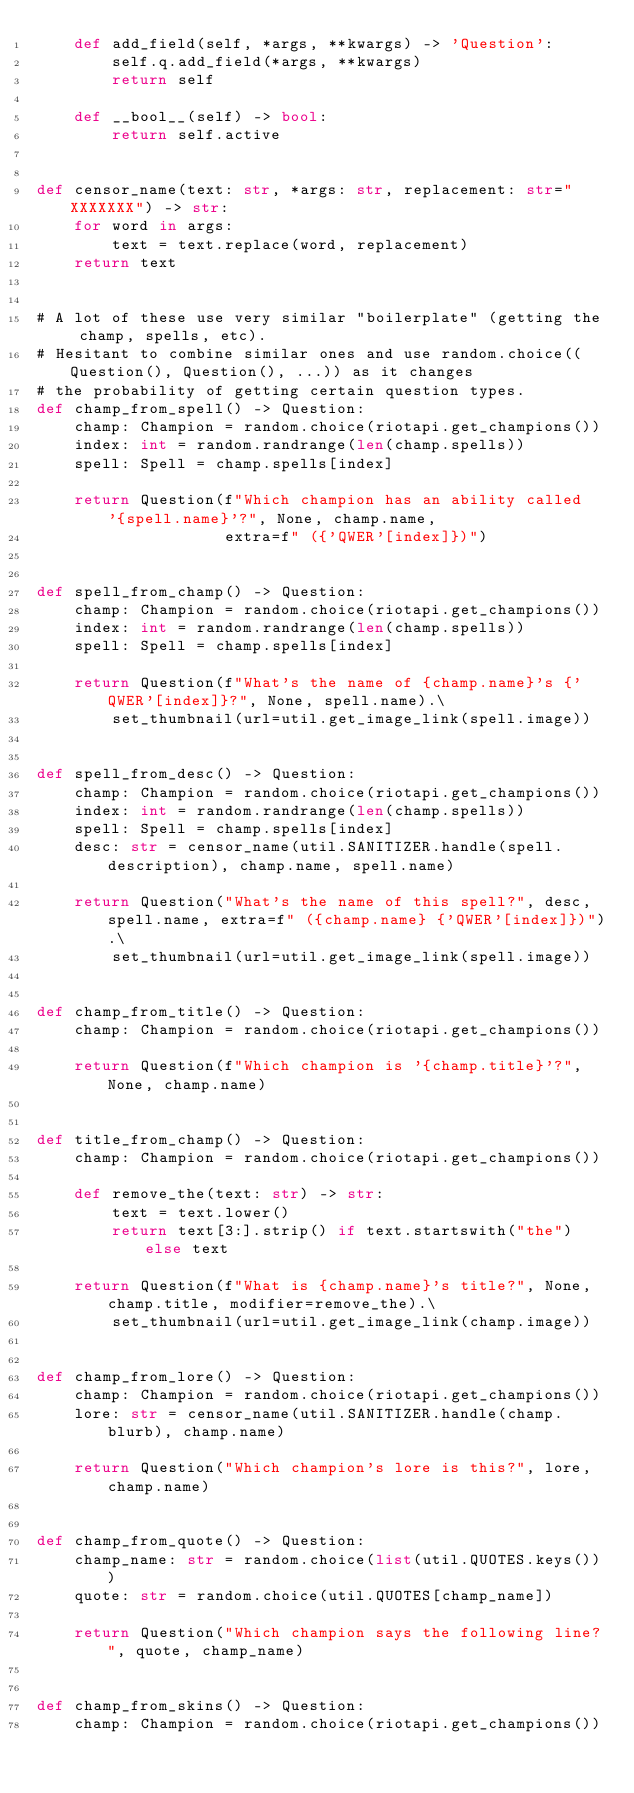Convert code to text. <code><loc_0><loc_0><loc_500><loc_500><_Python_>    def add_field(self, *args, **kwargs) -> 'Question':
        self.q.add_field(*args, **kwargs)
        return self

    def __bool__(self) -> bool:
        return self.active


def censor_name(text: str, *args: str, replacement: str="XXXXXXX") -> str:
    for word in args:
        text = text.replace(word, replacement)
    return text


# A lot of these use very similar "boilerplate" (getting the champ, spells, etc).
# Hesitant to combine similar ones and use random.choice((Question(), Question(), ...)) as it changes
# the probability of getting certain question types.
def champ_from_spell() -> Question:
    champ: Champion = random.choice(riotapi.get_champions())
    index: int = random.randrange(len(champ.spells))
    spell: Spell = champ.spells[index]

    return Question(f"Which champion has an ability called '{spell.name}'?", None, champ.name,
                    extra=f" ({'QWER'[index]})")


def spell_from_champ() -> Question:
    champ: Champion = random.choice(riotapi.get_champions())
    index: int = random.randrange(len(champ.spells))
    spell: Spell = champ.spells[index]

    return Question(f"What's the name of {champ.name}'s {'QWER'[index]}?", None, spell.name).\
        set_thumbnail(url=util.get_image_link(spell.image))


def spell_from_desc() -> Question:
    champ: Champion = random.choice(riotapi.get_champions())
    index: int = random.randrange(len(champ.spells))
    spell: Spell = champ.spells[index]
    desc: str = censor_name(util.SANITIZER.handle(spell.description), champ.name, spell.name)

    return Question("What's the name of this spell?", desc, spell.name, extra=f" ({champ.name} {'QWER'[index]})").\
        set_thumbnail(url=util.get_image_link(spell.image))


def champ_from_title() -> Question:
    champ: Champion = random.choice(riotapi.get_champions())

    return Question(f"Which champion is '{champ.title}'?", None, champ.name)


def title_from_champ() -> Question:
    champ: Champion = random.choice(riotapi.get_champions())

    def remove_the(text: str) -> str:
        text = text.lower()
        return text[3:].strip() if text.startswith("the") else text

    return Question(f"What is {champ.name}'s title?", None, champ.title, modifier=remove_the).\
        set_thumbnail(url=util.get_image_link(champ.image))


def champ_from_lore() -> Question:
    champ: Champion = random.choice(riotapi.get_champions())
    lore: str = censor_name(util.SANITIZER.handle(champ.blurb), champ.name)

    return Question("Which champion's lore is this?", lore, champ.name)


def champ_from_quote() -> Question:
    champ_name: str = random.choice(list(util.QUOTES.keys()))
    quote: str = random.choice(util.QUOTES[champ_name])

    return Question("Which champion says the following line?", quote, champ_name)


def champ_from_skins() -> Question:
    champ: Champion = random.choice(riotapi.get_champions())</code> 